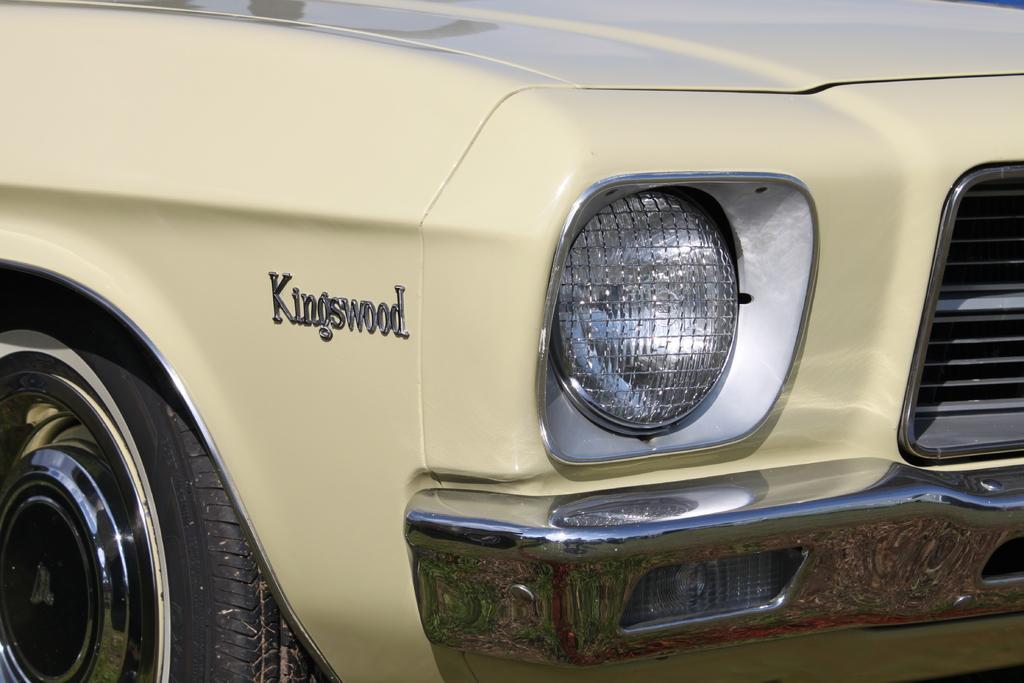How would you summarize this image in a sentence or two? In the picture we can see a front part of a car with headlight, bumper, and a part of the tire and name on the car is kings wood. 